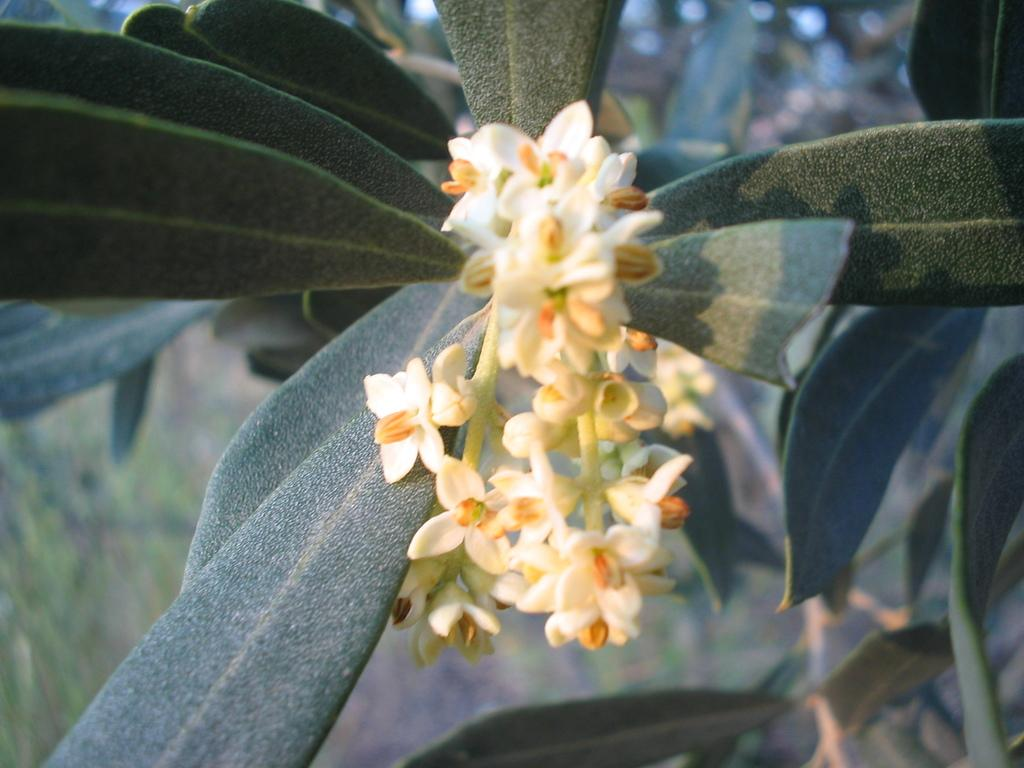What is present in the image? There is a plant in the image. What can be observed about the plant? The plant has a bunch of flowers. Does the plant have any pets in the image? There is no mention of a pet in the image, as it only features a plant with a bunch of flowers. 